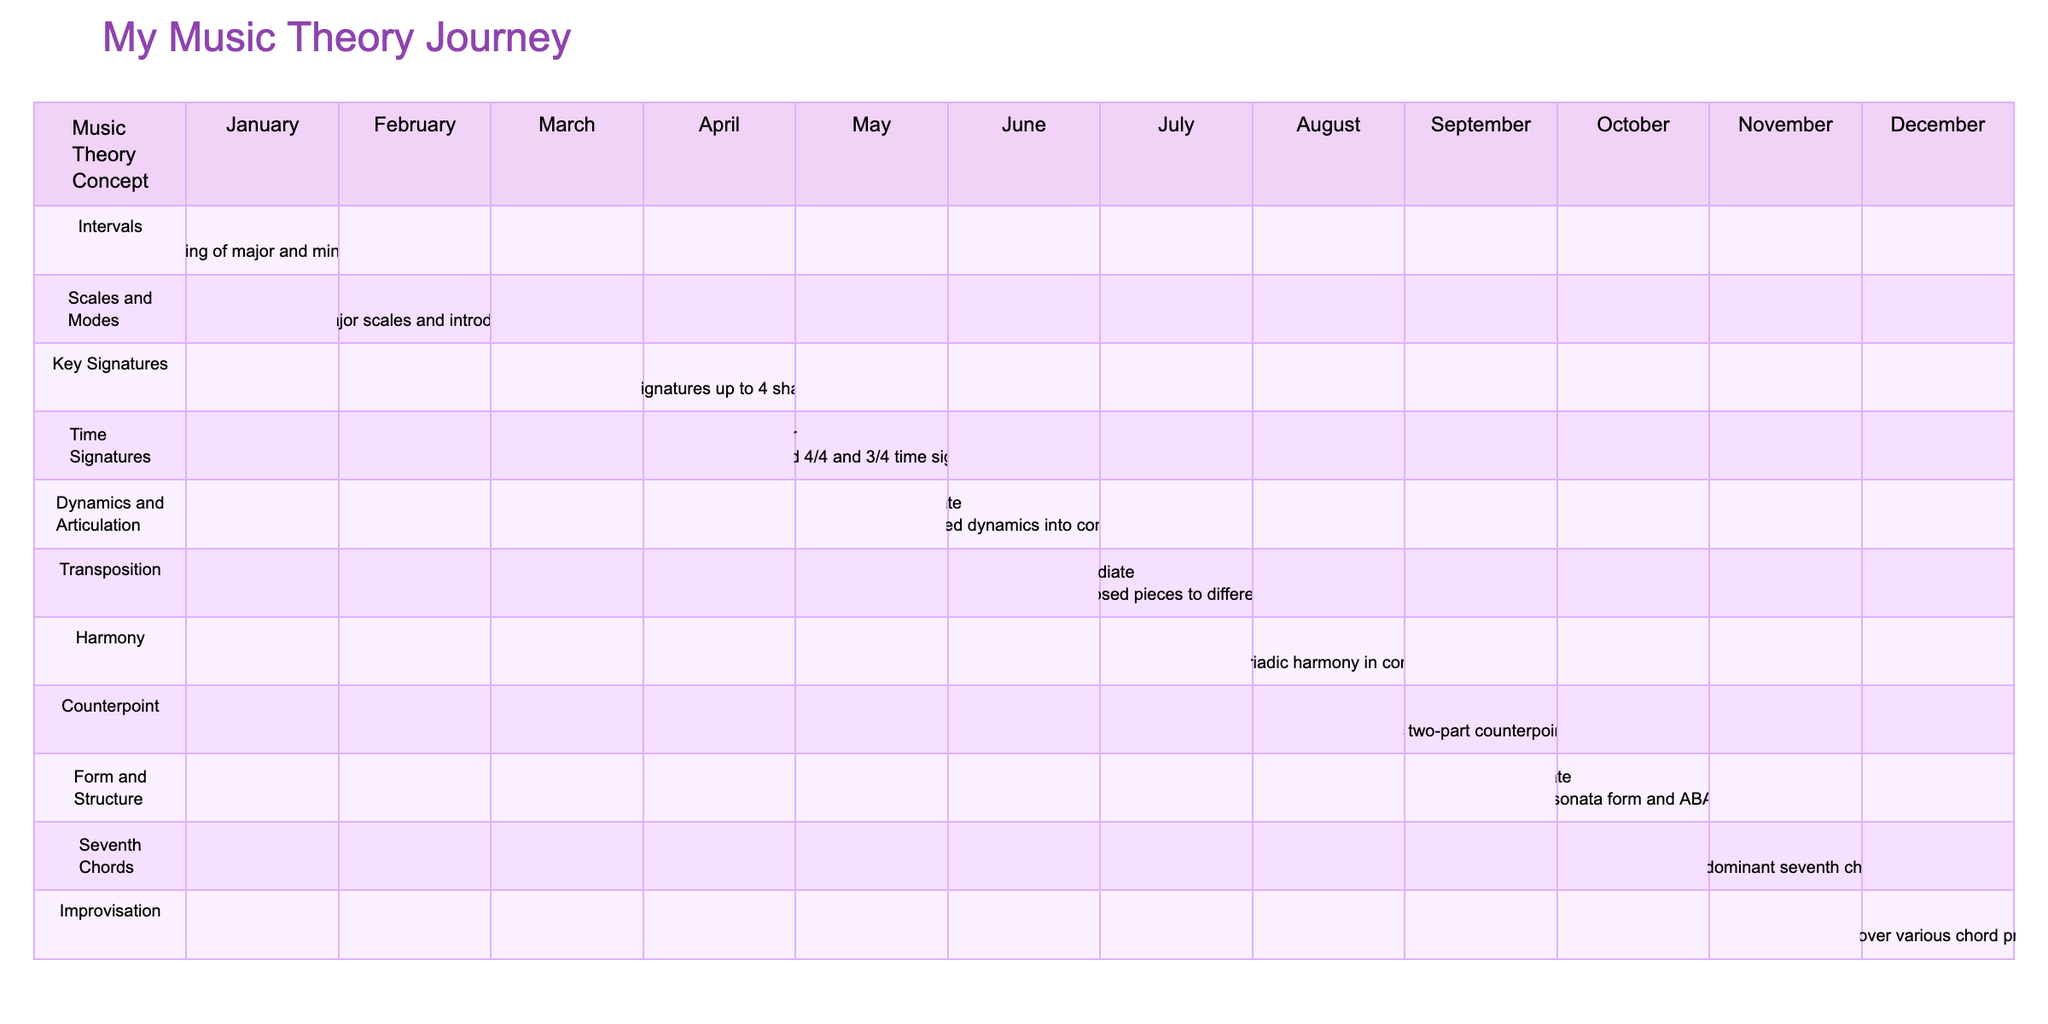What music theory concept was learned in June? In June, the table shows that the music theory concept learned was "Dynamics and Articulation."
Answer: Dynamics and Articulation What skill assessment was recorded for August? In August, the skill assessment stated in the table is "Advanced" according to the comments associated with the music theory concept learned that month.
Answer: Advanced Did I study any music theory concepts in March? The table indicates that there is no entry for March, meaning no music theory concepts were learned in that month.
Answer: No How many months recorded an "Intermediate" skill assessment? By reviewing the table, I find that the months with an "Intermediate" skill assessment are February, June, July, October, and November, which totals to 5 months.
Answer: 5 What was the newest music theory concept learned, and what was the skill assessment? December is the last month in the table, where the music theory concept "Improvisation" was learned, with an "Advanced" skill assessment recorded.
Answer: Improvisation, Advanced Which music theory concepts were studied in the second half of the year? The second half of the year (July to December) includes the concepts: "Transposition," "Harmony," "Counterpoint," "Form and Structure," "Seventh Chords," and "Improvisation."
Answer: Transposition, Harmony, Counterpoint, Form and Structure, Seventh Chords, Improvisation Which month had the lowest skill assessment, and what was it? By examining the table, I see that "Beginning" was the lowest skill assessment, which was recorded for September.
Answer: September, Beginning What is the average skill level from January to December? The skill levels can be assigned a numerical value: Beginner (1), Basic (2), Intermediate (3), and Advanced (4). The values corresponding to months are 1, 2, 3, 1, 3, 3, 3, 4, 1, 3, and 4. The total is 30, divided by 12 months equals an average score of 2.5, which corresponds to a skill level between Basic and Intermediate.
Answer: 2.5 In which months did I learn about chords? A review of the table reveals that chords were covered in August (Harmony) and November (Seventh Chords).
Answer: August, November How did my skill assessment progress from January to December? In January, I started with a "Beginner" level, which progressed to "Intermediate" in multiple months, reaching "Advanced" by August and December, indicating an upward trend in skill level throughout the year.
Answer: Progressed from Beginner to Advanced 